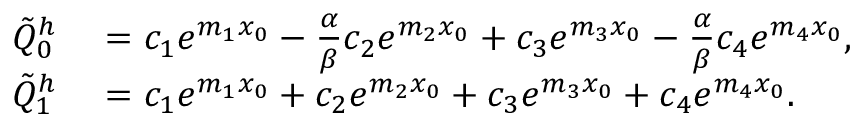Convert formula to latex. <formula><loc_0><loc_0><loc_500><loc_500>\begin{array} { r l } { \tilde { Q } _ { 0 } ^ { h } } & = c _ { 1 } e ^ { m _ { 1 } x _ { 0 } } - \frac { \alpha } { \beta } c _ { 2 } e ^ { m _ { 2 } x _ { 0 } } + c _ { 3 } e ^ { m _ { 3 } x _ { 0 } } - \frac { \alpha } { \beta } c _ { 4 } e ^ { m _ { 4 } x _ { 0 } } , } \\ { \tilde { Q } _ { 1 } ^ { h } } & = c _ { 1 } e ^ { m _ { 1 } x _ { 0 } } + c _ { 2 } e ^ { m _ { 2 } x _ { 0 } } + c _ { 3 } e ^ { m _ { 3 } x _ { 0 } } + c _ { 4 } e ^ { m _ { 4 } x _ { 0 } } . } \end{array}</formula> 